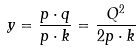Convert formula to latex. <formula><loc_0><loc_0><loc_500><loc_500>y = \frac { p \cdot q } { p \cdot k } = \frac { Q ^ { 2 } } { 2 p \cdot k }</formula> 